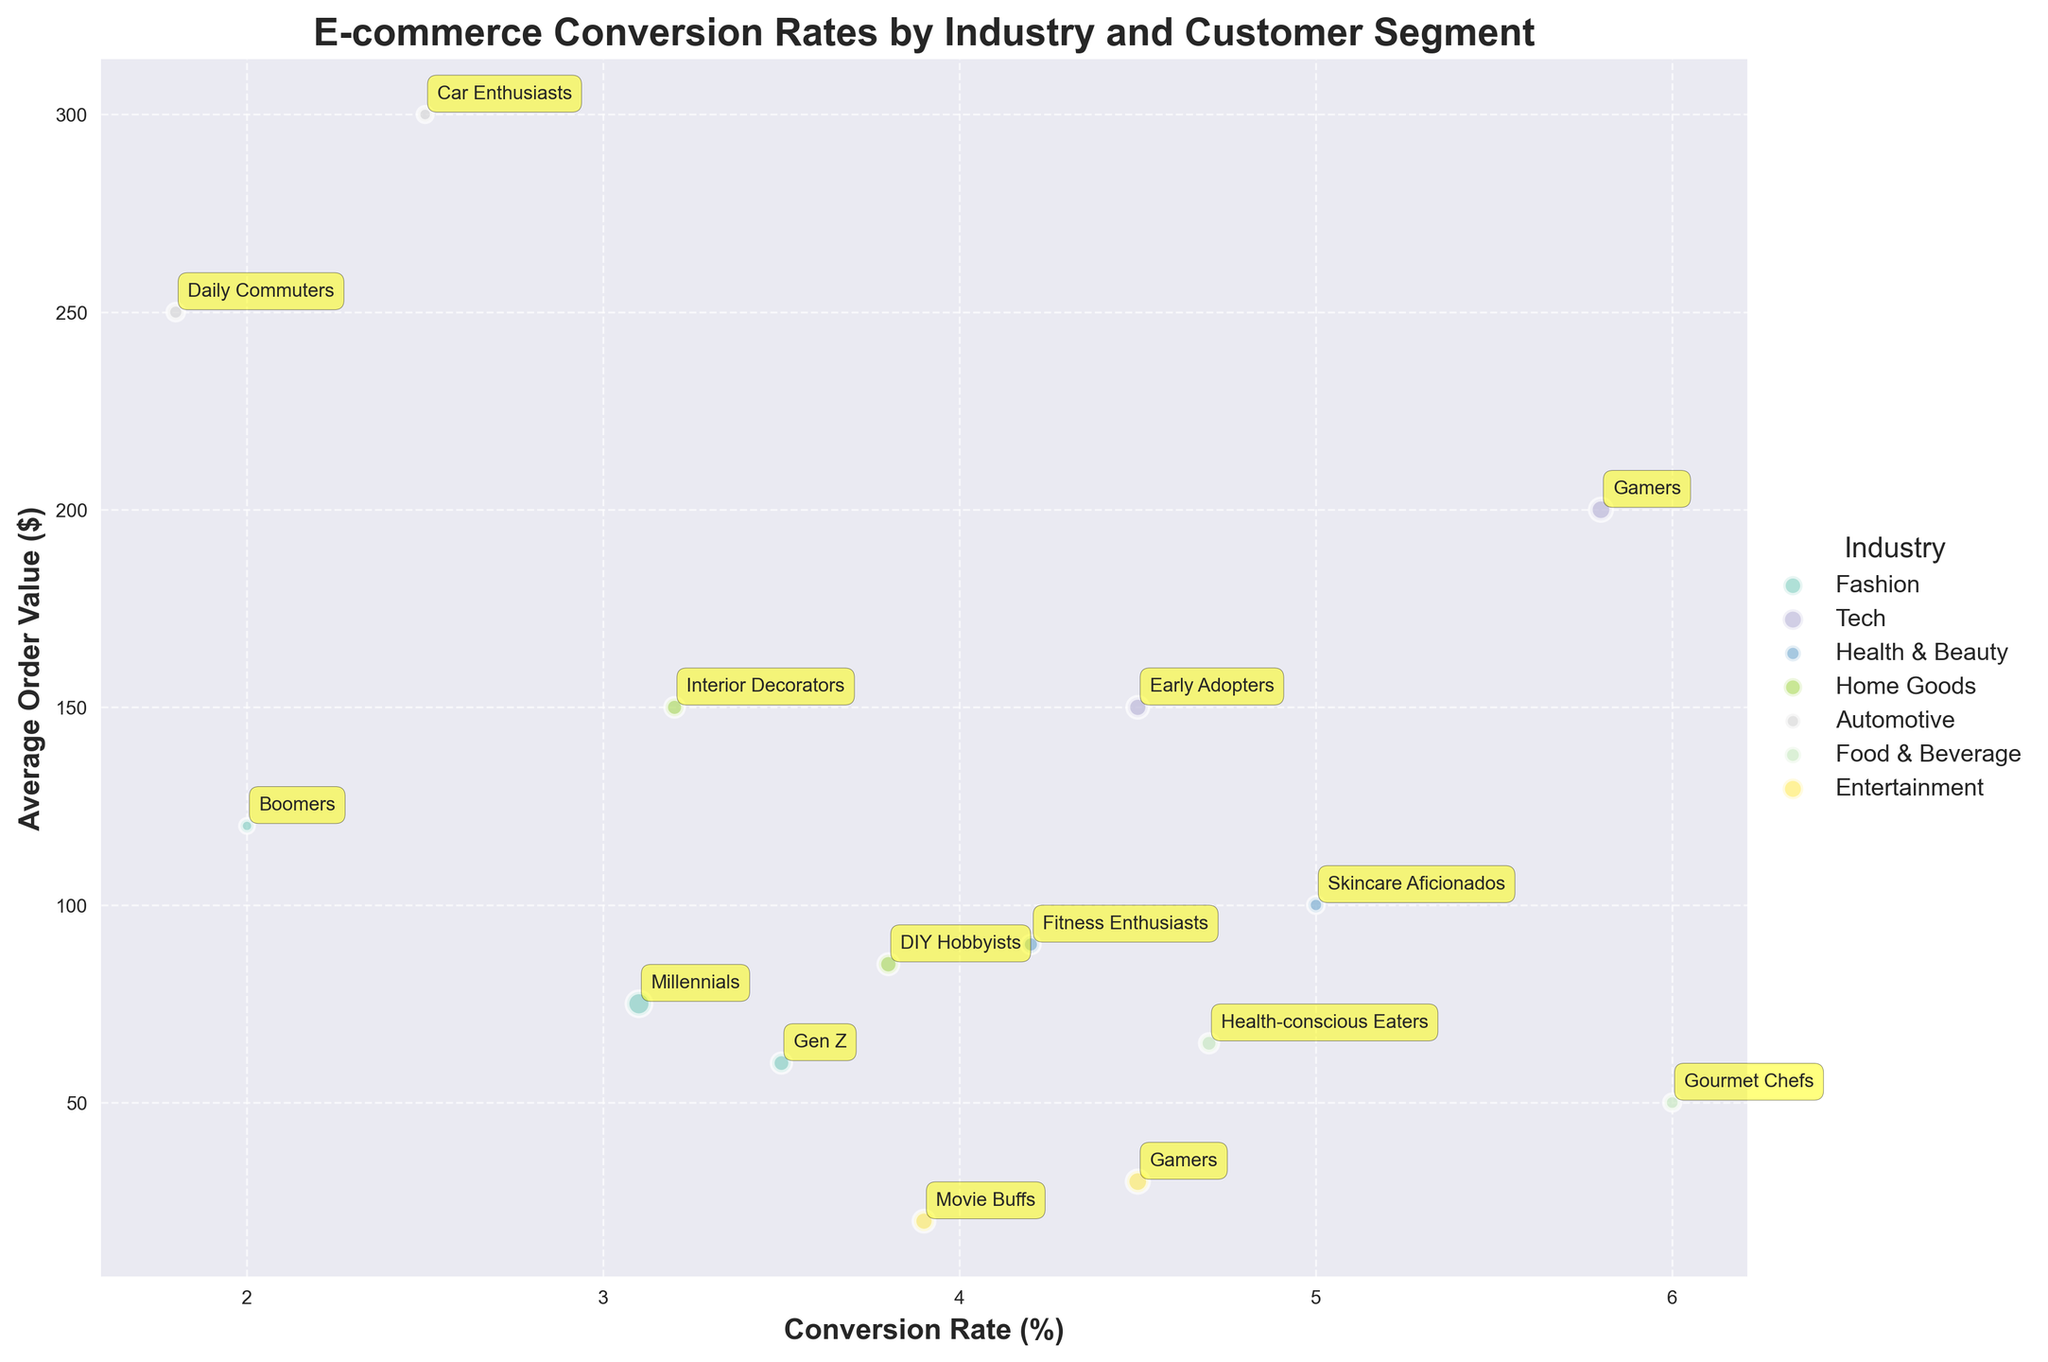What is the title of the bubble chart? The title of the bubble chart is usually displayed at the top of the figure. In this case, it clearly states the main subject of the data being represented.
Answer: E-commerce Conversion Rates by Industry and Customer Segment Which customer segment in the Tech industry has the highest conversion rate? To find this, look at the conversion rates on the x-axis for the Tech industry bubbles. Compare the conversion rates for both "Gamers" and "Early Adopters".
Answer: Gamers What is the average order value of Skincare Aficionados in the Health & Beauty industry? Locate the bubble labeled "Skincare Aficionados" in the Health & Beauty industry and check its corresponding position on the y-axis, which represents the average order value.
Answer: $100 In which industry do Gamers have a higher conversion rate, Tech or Entertainment? Find the bubbles labeled "Gamers" in both the Tech and Entertainment industries and compare their positions on the x-axis, which represents the conversion rate.
Answer: Tech Which customer segment has the largest bubble size in this chart? Observe the sizes of all the bubbles in the chart and identify the largest one, indicating the highest traffic.
Answer: Millennials in Fashion Which industry has the highest variation in conversion rates among its customer segments? Look at the spread of the bubbles within each industry along the x-axis. The industry with the widest range between the lowest and highest conversion rates has the highest variation.
Answer: Fashion What are the conversion rate and average order value for Daily Commuters in the Automotive industry? Locate the bubble labeled "Daily Commuters" in the Automotive industry. Read the conversion rate from the x-axis and the average order value from the y-axis.
Answer: 1.8% and $250 Which industry appears to target segments with higher average order values overall? Compare the vertical spread of the bubbles across different industries. The industry with bubbles consistently positioned higher on the y-axis has higher average order values.
Answer: Automotive What is the relationship between traffic and bubble size in this chart? The bubble size is indicative of the traffic. Although exact numerical values are not displayed, a rough comparison can be made. Larger bubbles represent higher traffic.
Answer: Larger bubbles indicate higher traffic 